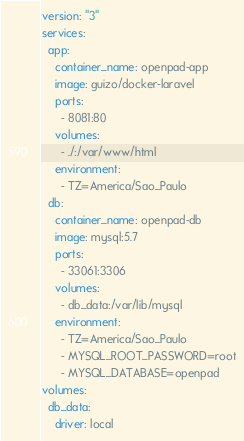<code> <loc_0><loc_0><loc_500><loc_500><_YAML_>version: "3"
services:
  app:
    container_name: openpad-app
    image: guizo/docker-laravel
    ports:
      - 8081:80
    volumes:
      - ./:/var/www/html
    environment:
      - TZ=America/Sao_Paulo
  db:
    container_name: openpad-db
    image: mysql:5.7
    ports:
      - 33061:3306
    volumes:
      - db_data:/var/lib/mysql
    environment:
      - TZ=America/Sao_Paulo
      - MYSQL_ROOT_PASSWORD=root
      - MYSQL_DATABASE=openpad
volumes:
  db_data:
    driver: local
</code> 